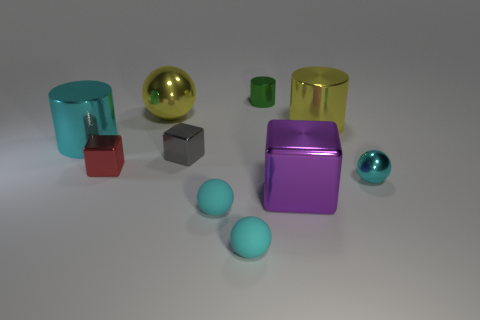What number of other objects are the same shape as the purple object?
Offer a terse response. 2. Do the purple metal object and the metal cylinder left of the green metallic cylinder have the same size?
Your answer should be very brief. Yes. How many objects are big yellow cylinders or small green cylinders?
Your answer should be compact. 2. How many other objects are the same size as the green cylinder?
Your answer should be compact. 5. Is the color of the large shiny sphere the same as the small shiny ball to the right of the gray cube?
Your answer should be compact. No. What number of balls are large metallic things or small cyan rubber things?
Provide a succinct answer. 3. Are there any other things of the same color as the big cube?
Ensure brevity in your answer.  No. Are the big cyan thing and the small object behind the big metal sphere made of the same material?
Provide a succinct answer. Yes. How many objects are tiny cyan objects that are to the right of the small green metallic cylinder or small cyan things?
Give a very brief answer. 3. Is there a big object that has the same color as the large sphere?
Give a very brief answer. Yes. 